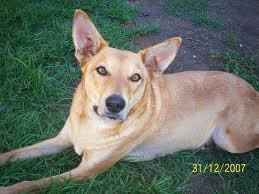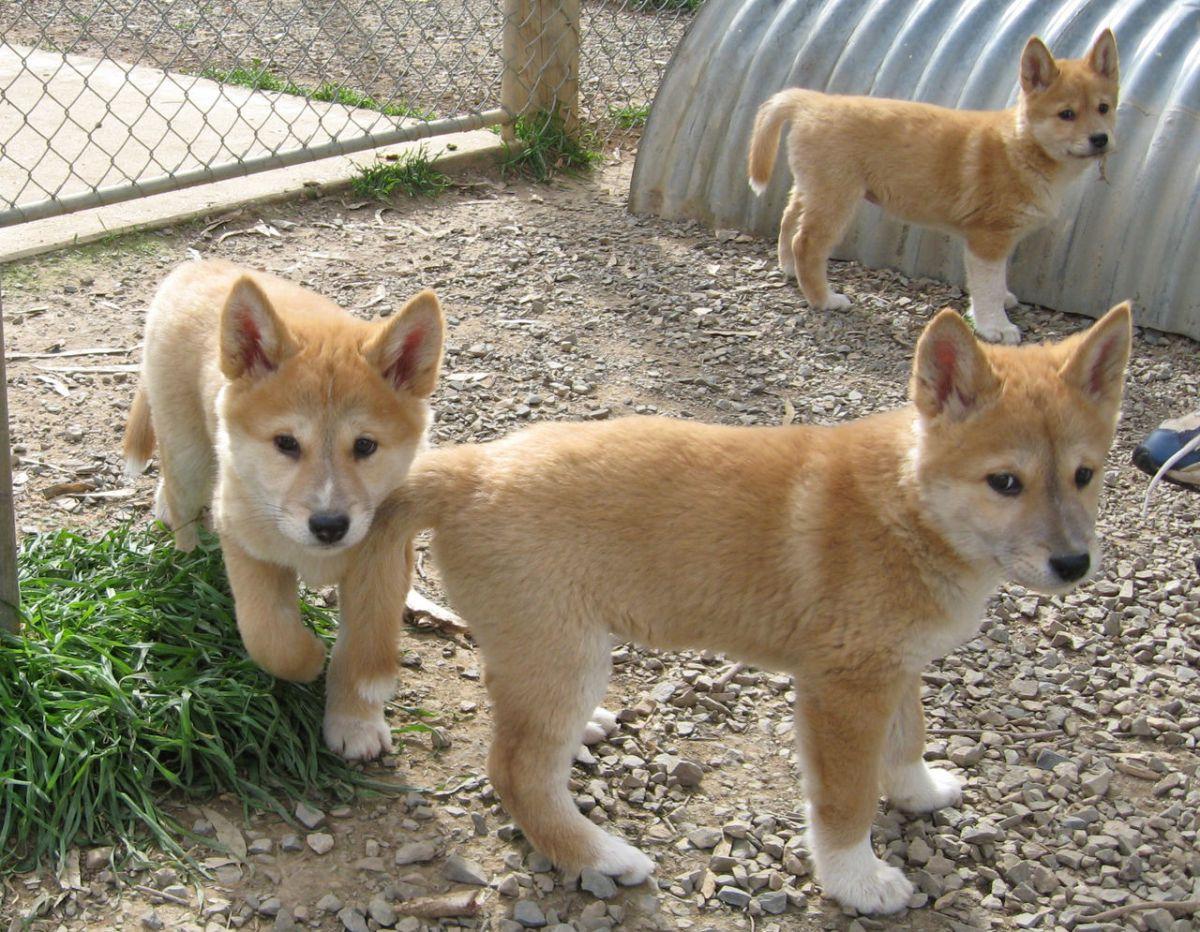The first image is the image on the left, the second image is the image on the right. Considering the images on both sides, is "The dog in the image on the left is laying down on the ground." valid? Answer yes or no. Yes. The first image is the image on the left, the second image is the image on the right. Analyze the images presented: Is the assertion "The left image features one reclining orange dog, and the right image includes at least one standing orange puppy." valid? Answer yes or no. Yes. 